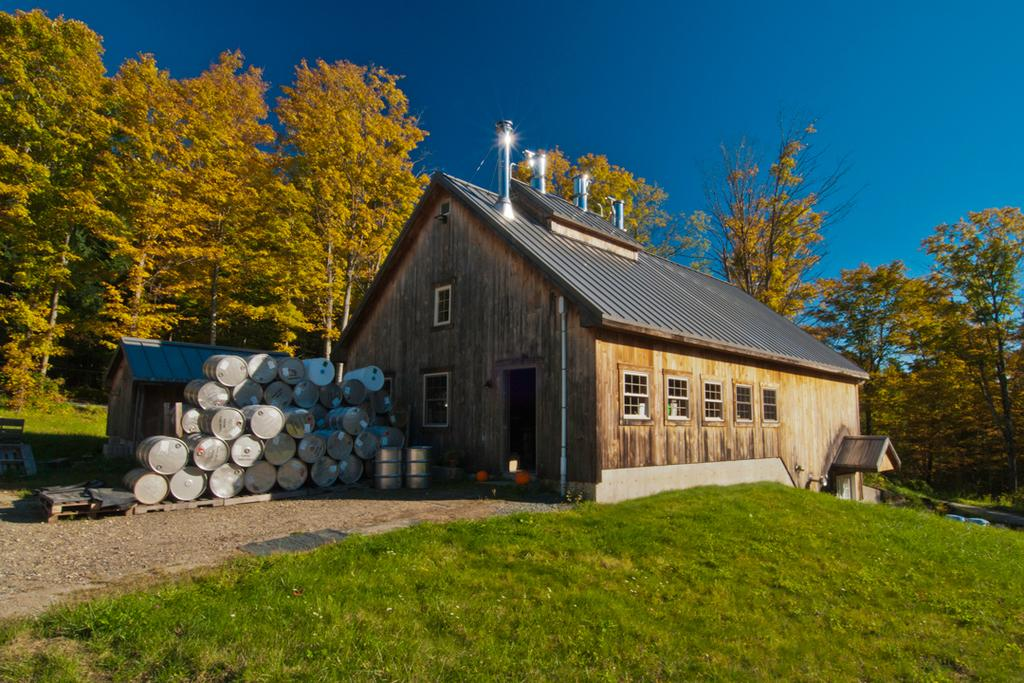What type of structures can be seen in the image? There are houses in the image. What musical instruments are present in the image? There are drums in the image. What type of vegetation is visible in the image? There is grass and trees in the image. What else can be found on the ground in the image? There are other objects on the ground in the image. What is visible in the background of the image? The sky is visible in the background of the image. How many babies are holding pickles in the image? There are no babies or pickles present in the image. What type of hand is shown interacting with the drums in the image? There are no hands shown interacting with the drums in the image; only the drums themselves are visible. 